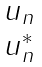Convert formula to latex. <formula><loc_0><loc_0><loc_500><loc_500>\begin{matrix} u _ { n } \\ u _ { n } ^ { * } \end{matrix}</formula> 